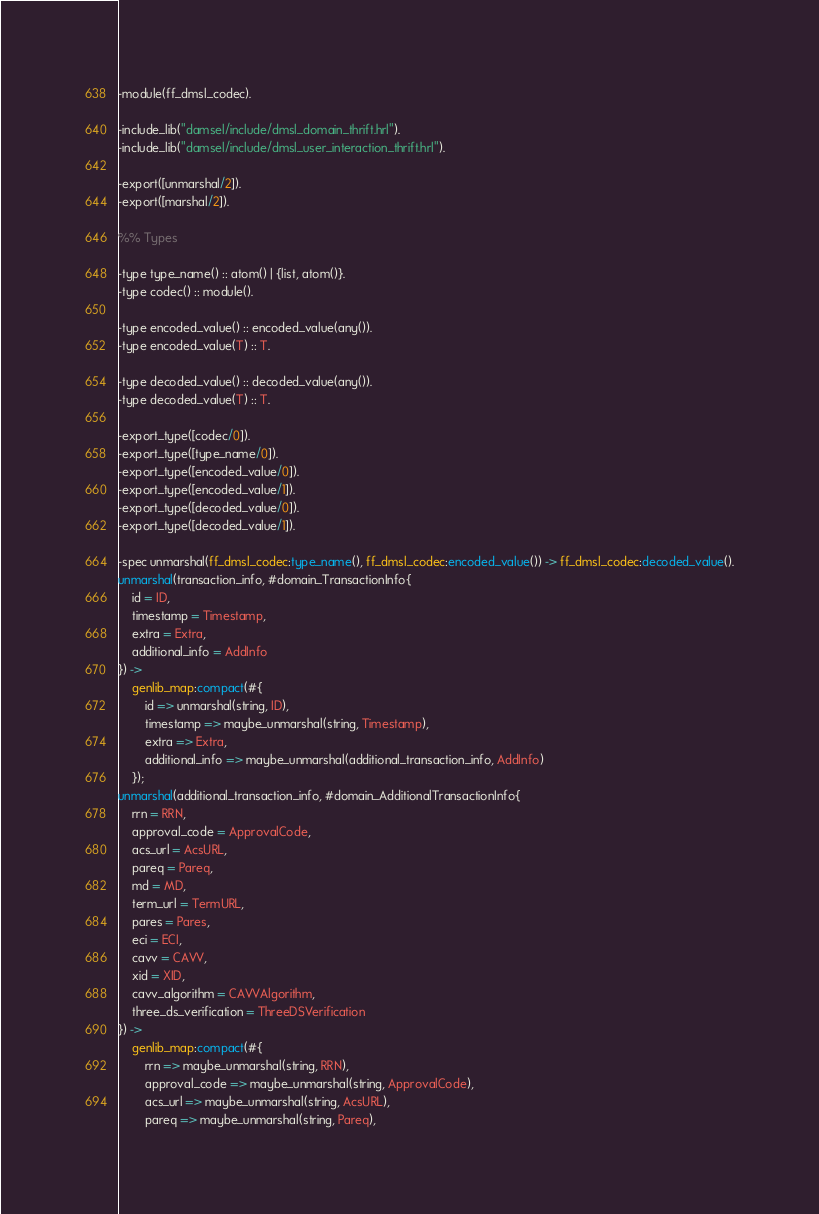<code> <loc_0><loc_0><loc_500><loc_500><_Erlang_>-module(ff_dmsl_codec).

-include_lib("damsel/include/dmsl_domain_thrift.hrl").
-include_lib("damsel/include/dmsl_user_interaction_thrift.hrl").

-export([unmarshal/2]).
-export([marshal/2]).

%% Types

-type type_name() :: atom() | {list, atom()}.
-type codec() :: module().

-type encoded_value() :: encoded_value(any()).
-type encoded_value(T) :: T.

-type decoded_value() :: decoded_value(any()).
-type decoded_value(T) :: T.

-export_type([codec/0]).
-export_type([type_name/0]).
-export_type([encoded_value/0]).
-export_type([encoded_value/1]).
-export_type([decoded_value/0]).
-export_type([decoded_value/1]).

-spec unmarshal(ff_dmsl_codec:type_name(), ff_dmsl_codec:encoded_value()) -> ff_dmsl_codec:decoded_value().
unmarshal(transaction_info, #domain_TransactionInfo{
    id = ID,
    timestamp = Timestamp,
    extra = Extra,
    additional_info = AddInfo
}) ->
    genlib_map:compact(#{
        id => unmarshal(string, ID),
        timestamp => maybe_unmarshal(string, Timestamp),
        extra => Extra,
        additional_info => maybe_unmarshal(additional_transaction_info, AddInfo)
    });
unmarshal(additional_transaction_info, #domain_AdditionalTransactionInfo{
    rrn = RRN,
    approval_code = ApprovalCode,
    acs_url = AcsURL,
    pareq = Pareq,
    md = MD,
    term_url = TermURL,
    pares = Pares,
    eci = ECI,
    cavv = CAVV,
    xid = XID,
    cavv_algorithm = CAVVAlgorithm,
    three_ds_verification = ThreeDSVerification
}) ->
    genlib_map:compact(#{
        rrn => maybe_unmarshal(string, RRN),
        approval_code => maybe_unmarshal(string, ApprovalCode),
        acs_url => maybe_unmarshal(string, AcsURL),
        pareq => maybe_unmarshal(string, Pareq),</code> 